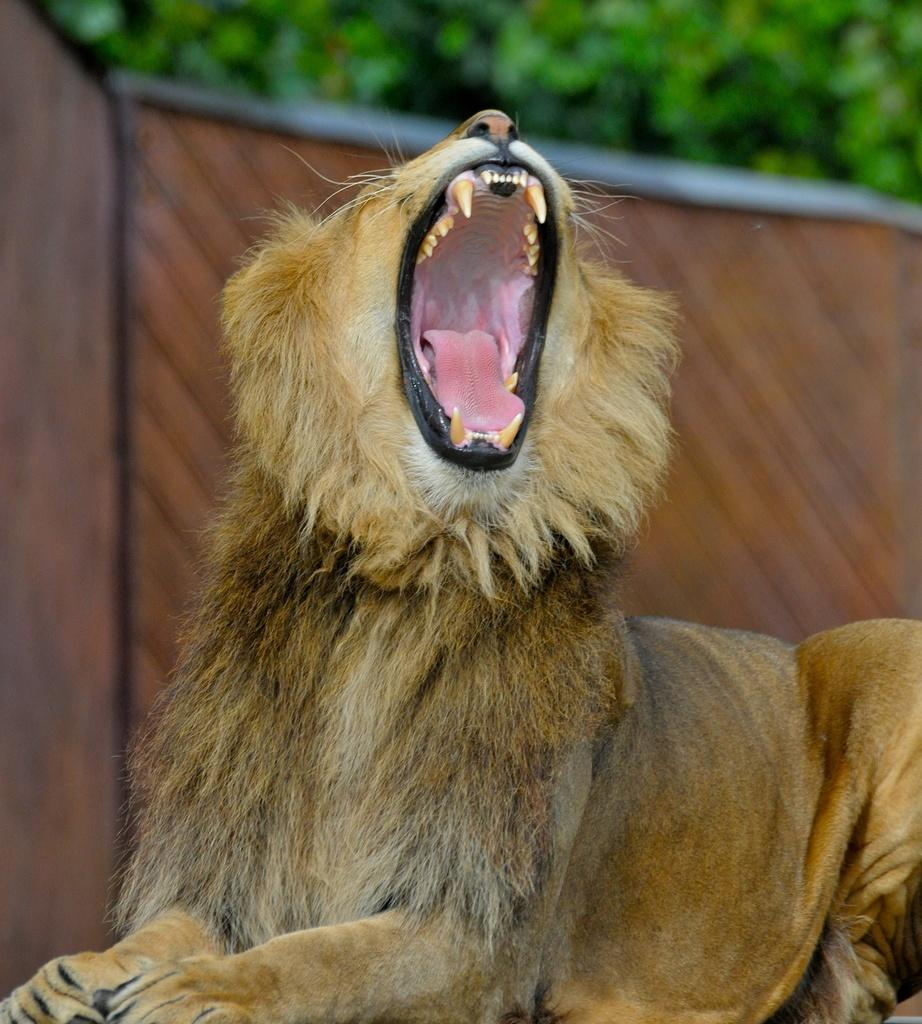What animal is in the image? There is a lion in the image. What is the lion doing in the image? The lion is yawning. How wide is the lion's mouth in the image? The lion's mouth is wide open in the image. What is behind the lion in the image? There is a wall behind the lion. What can be seen in the background of the image? Trees are present in the background of the image. What type of box is the lion playing with in the image? There is no box present in the image, and the lion is not playing with any object. 